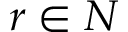Convert formula to latex. <formula><loc_0><loc_0><loc_500><loc_500>r \in N</formula> 